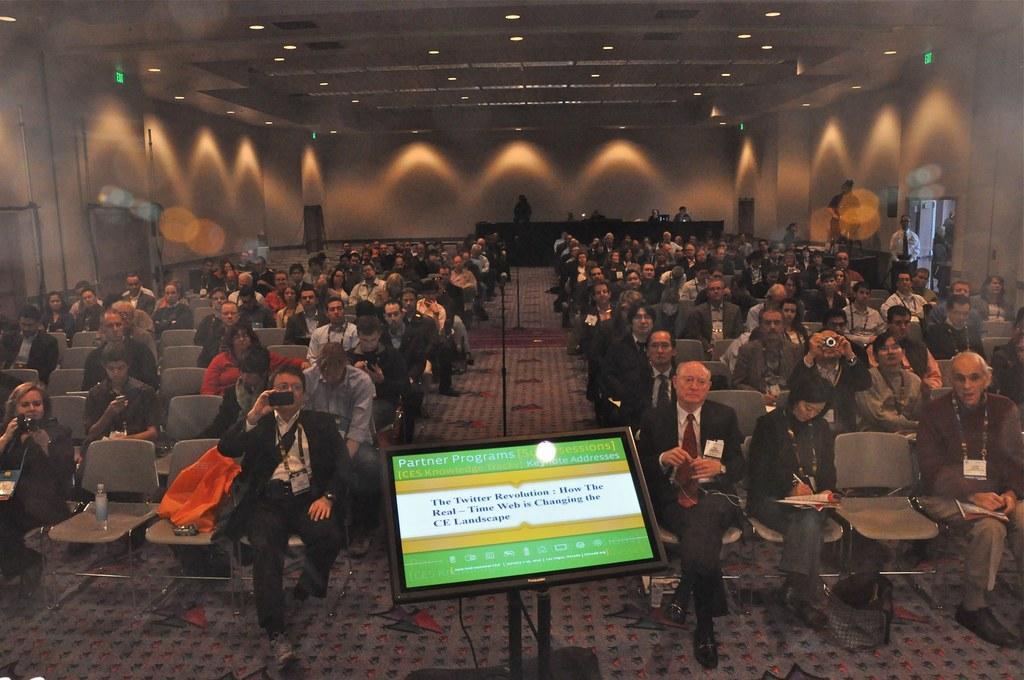Could you give a brief overview of what you see in this image? In this image I can see number of persons sitting on chairs and some of them are holding cameras in their hands and some are holding books and pens in their hands. I can see the screen. In the background I can see few persons standing, the wall, few lights and the ceiling. 